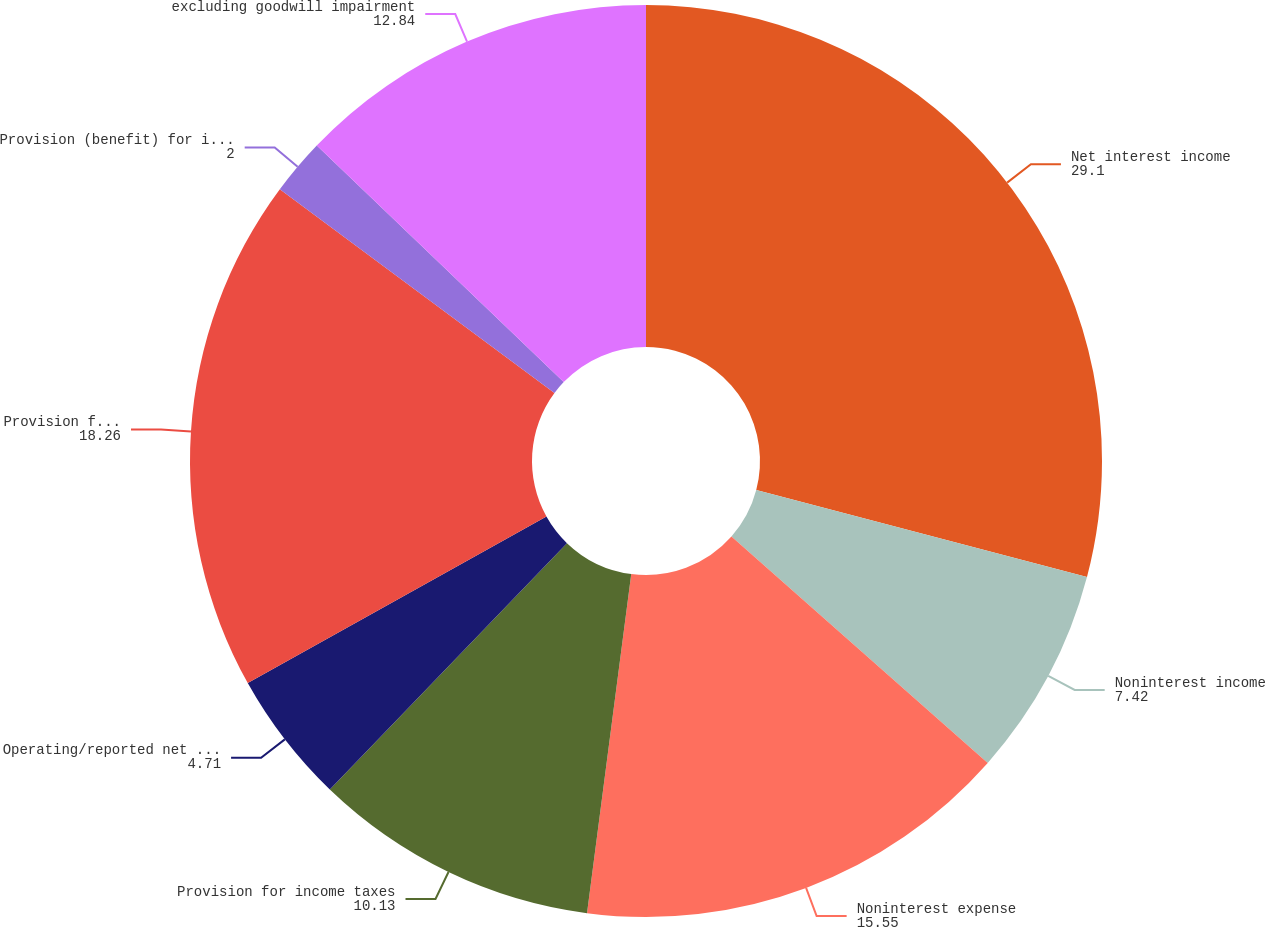Convert chart. <chart><loc_0><loc_0><loc_500><loc_500><pie_chart><fcel>Net interest income<fcel>Noninterest income<fcel>Noninterest expense<fcel>Provision for income taxes<fcel>Operating/reported net income<fcel>Provision for credit losses<fcel>Provision (benefit) for income<fcel>excluding goodwill impairment<nl><fcel>29.1%<fcel>7.42%<fcel>15.55%<fcel>10.13%<fcel>4.71%<fcel>18.26%<fcel>2.0%<fcel>12.84%<nl></chart> 